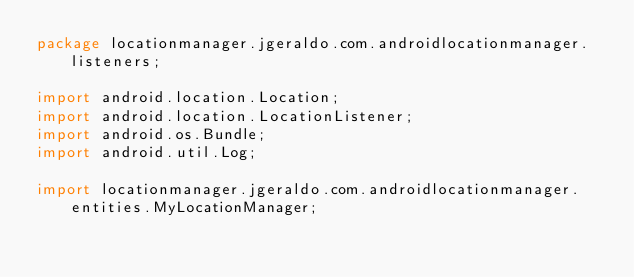Convert code to text. <code><loc_0><loc_0><loc_500><loc_500><_Java_>package locationmanager.jgeraldo.com.androidlocationmanager.listeners;

import android.location.Location;
import android.location.LocationListener;
import android.os.Bundle;
import android.util.Log;

import locationmanager.jgeraldo.com.androidlocationmanager.entities.MyLocationManager;</code> 